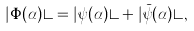Convert formula to latex. <formula><loc_0><loc_0><loc_500><loc_500>| \Phi ( \alpha ) \rangle = | \psi ( \alpha ) \rangle + | \bar { \psi } ( \alpha ) \rangle ,</formula> 